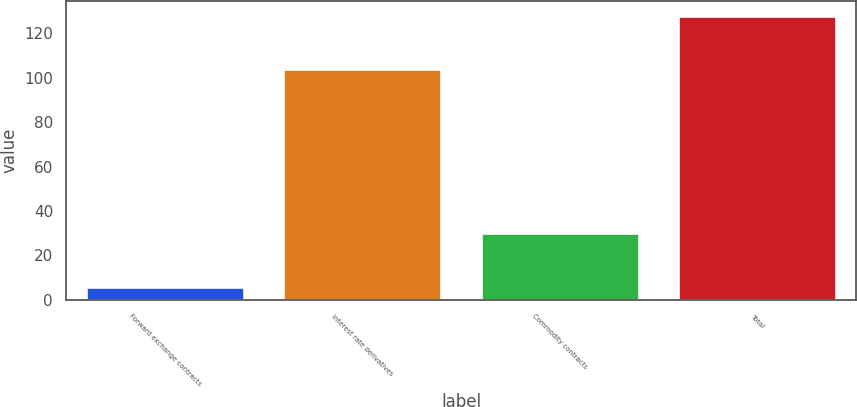Convert chart. <chart><loc_0><loc_0><loc_500><loc_500><bar_chart><fcel>Forward exchange contracts<fcel>Interest rate derivatives<fcel>Commodity contracts<fcel>Total<nl><fcel>6<fcel>104<fcel>30<fcel>128<nl></chart> 